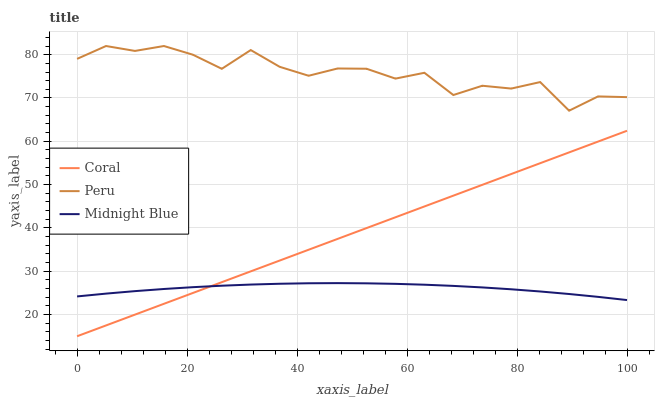Does Peru have the minimum area under the curve?
Answer yes or no. No. Does Midnight Blue have the maximum area under the curve?
Answer yes or no. No. Is Midnight Blue the smoothest?
Answer yes or no. No. Is Midnight Blue the roughest?
Answer yes or no. No. Does Midnight Blue have the lowest value?
Answer yes or no. No. Does Midnight Blue have the highest value?
Answer yes or no. No. Is Midnight Blue less than Peru?
Answer yes or no. Yes. Is Peru greater than Coral?
Answer yes or no. Yes. Does Midnight Blue intersect Peru?
Answer yes or no. No. 